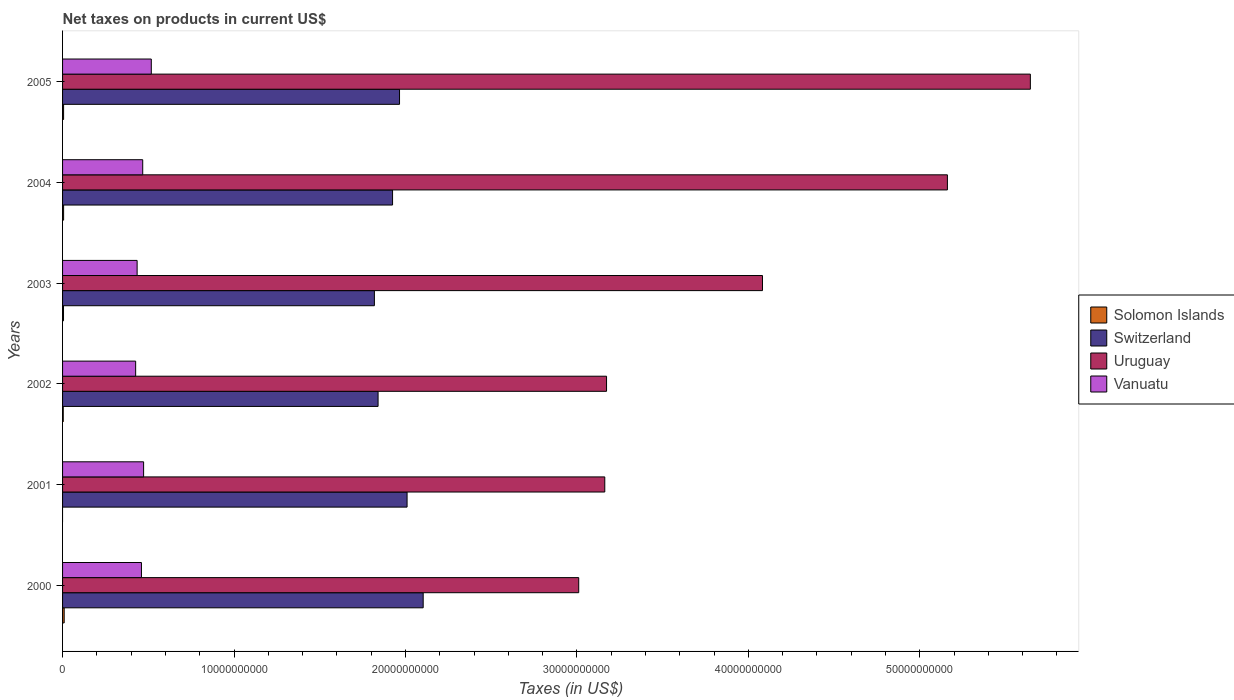How many groups of bars are there?
Your response must be concise. 6. How many bars are there on the 1st tick from the top?
Your answer should be compact. 4. How many bars are there on the 4th tick from the bottom?
Give a very brief answer. 4. What is the net taxes on products in Switzerland in 2002?
Your answer should be very brief. 1.84e+1. Across all years, what is the maximum net taxes on products in Solomon Islands?
Offer a very short reply. 9.44e+07. Across all years, what is the minimum net taxes on products in Switzerland?
Ensure brevity in your answer.  1.82e+1. What is the total net taxes on products in Solomon Islands in the graph?
Offer a terse response. 3.12e+08. What is the difference between the net taxes on products in Switzerland in 2000 and that in 2002?
Give a very brief answer. 2.63e+09. What is the difference between the net taxes on products in Uruguay in 2004 and the net taxes on products in Solomon Islands in 2005?
Provide a short and direct response. 5.16e+1. What is the average net taxes on products in Switzerland per year?
Give a very brief answer. 1.94e+1. In the year 2004, what is the difference between the net taxes on products in Vanuatu and net taxes on products in Uruguay?
Offer a terse response. -4.69e+1. What is the ratio of the net taxes on products in Vanuatu in 2002 to that in 2005?
Make the answer very short. 0.82. Is the difference between the net taxes on products in Vanuatu in 2000 and 2005 greater than the difference between the net taxes on products in Uruguay in 2000 and 2005?
Your response must be concise. Yes. What is the difference between the highest and the second highest net taxes on products in Vanuatu?
Offer a very short reply. 4.49e+08. What is the difference between the highest and the lowest net taxes on products in Uruguay?
Ensure brevity in your answer.  2.63e+1. In how many years, is the net taxes on products in Solomon Islands greater than the average net taxes on products in Solomon Islands taken over all years?
Provide a succinct answer. 4. Is it the case that in every year, the sum of the net taxes on products in Solomon Islands and net taxes on products in Uruguay is greater than the sum of net taxes on products in Vanuatu and net taxes on products in Switzerland?
Your answer should be very brief. No. How many bars are there?
Offer a terse response. 23. How many years are there in the graph?
Ensure brevity in your answer.  6. What is the difference between two consecutive major ticks on the X-axis?
Your answer should be very brief. 1.00e+1. Does the graph contain grids?
Give a very brief answer. No. Where does the legend appear in the graph?
Provide a succinct answer. Center right. How many legend labels are there?
Your answer should be very brief. 4. How are the legend labels stacked?
Provide a short and direct response. Vertical. What is the title of the graph?
Make the answer very short. Net taxes on products in current US$. What is the label or title of the X-axis?
Your answer should be very brief. Taxes (in US$). What is the label or title of the Y-axis?
Ensure brevity in your answer.  Years. What is the Taxes (in US$) in Solomon Islands in 2000?
Offer a terse response. 9.44e+07. What is the Taxes (in US$) in Switzerland in 2000?
Make the answer very short. 2.10e+1. What is the Taxes (in US$) of Uruguay in 2000?
Your answer should be very brief. 3.01e+1. What is the Taxes (in US$) in Vanuatu in 2000?
Make the answer very short. 4.60e+09. What is the Taxes (in US$) of Switzerland in 2001?
Offer a very short reply. 2.01e+1. What is the Taxes (in US$) of Uruguay in 2001?
Your answer should be very brief. 3.16e+1. What is the Taxes (in US$) of Vanuatu in 2001?
Provide a short and direct response. 4.73e+09. What is the Taxes (in US$) of Solomon Islands in 2002?
Ensure brevity in your answer.  4.03e+07. What is the Taxes (in US$) in Switzerland in 2002?
Your answer should be very brief. 1.84e+1. What is the Taxes (in US$) in Uruguay in 2002?
Your answer should be very brief. 3.17e+1. What is the Taxes (in US$) of Vanuatu in 2002?
Ensure brevity in your answer.  4.26e+09. What is the Taxes (in US$) of Solomon Islands in 2003?
Give a very brief answer. 5.58e+07. What is the Taxes (in US$) in Switzerland in 2003?
Your response must be concise. 1.82e+1. What is the Taxes (in US$) in Uruguay in 2003?
Keep it short and to the point. 4.08e+1. What is the Taxes (in US$) of Vanuatu in 2003?
Provide a short and direct response. 4.35e+09. What is the Taxes (in US$) of Solomon Islands in 2004?
Keep it short and to the point. 6.11e+07. What is the Taxes (in US$) in Switzerland in 2004?
Your answer should be very brief. 1.92e+1. What is the Taxes (in US$) in Uruguay in 2004?
Your answer should be very brief. 5.16e+1. What is the Taxes (in US$) in Vanuatu in 2004?
Offer a terse response. 4.68e+09. What is the Taxes (in US$) in Solomon Islands in 2005?
Offer a very short reply. 6.03e+07. What is the Taxes (in US$) of Switzerland in 2005?
Give a very brief answer. 1.97e+1. What is the Taxes (in US$) of Uruguay in 2005?
Offer a terse response. 5.64e+1. What is the Taxes (in US$) in Vanuatu in 2005?
Make the answer very short. 5.18e+09. Across all years, what is the maximum Taxes (in US$) of Solomon Islands?
Your answer should be compact. 9.44e+07. Across all years, what is the maximum Taxes (in US$) in Switzerland?
Keep it short and to the point. 2.10e+1. Across all years, what is the maximum Taxes (in US$) in Uruguay?
Provide a succinct answer. 5.64e+1. Across all years, what is the maximum Taxes (in US$) of Vanuatu?
Provide a succinct answer. 5.18e+09. Across all years, what is the minimum Taxes (in US$) of Switzerland?
Give a very brief answer. 1.82e+1. Across all years, what is the minimum Taxes (in US$) in Uruguay?
Provide a short and direct response. 3.01e+1. Across all years, what is the minimum Taxes (in US$) of Vanuatu?
Offer a terse response. 4.26e+09. What is the total Taxes (in US$) of Solomon Islands in the graph?
Ensure brevity in your answer.  3.12e+08. What is the total Taxes (in US$) of Switzerland in the graph?
Keep it short and to the point. 1.17e+11. What is the total Taxes (in US$) of Uruguay in the graph?
Your answer should be compact. 2.42e+11. What is the total Taxes (in US$) in Vanuatu in the graph?
Give a very brief answer. 2.78e+1. What is the difference between the Taxes (in US$) in Switzerland in 2000 and that in 2001?
Give a very brief answer. 9.39e+08. What is the difference between the Taxes (in US$) in Uruguay in 2000 and that in 2001?
Provide a short and direct response. -1.52e+09. What is the difference between the Taxes (in US$) of Vanuatu in 2000 and that in 2001?
Keep it short and to the point. -1.26e+08. What is the difference between the Taxes (in US$) of Solomon Islands in 2000 and that in 2002?
Keep it short and to the point. 5.41e+07. What is the difference between the Taxes (in US$) of Switzerland in 2000 and that in 2002?
Make the answer very short. 2.63e+09. What is the difference between the Taxes (in US$) of Uruguay in 2000 and that in 2002?
Keep it short and to the point. -1.62e+09. What is the difference between the Taxes (in US$) of Vanuatu in 2000 and that in 2002?
Your answer should be compact. 3.38e+08. What is the difference between the Taxes (in US$) of Solomon Islands in 2000 and that in 2003?
Keep it short and to the point. 3.86e+07. What is the difference between the Taxes (in US$) in Switzerland in 2000 and that in 2003?
Your answer should be compact. 2.85e+09. What is the difference between the Taxes (in US$) of Uruguay in 2000 and that in 2003?
Keep it short and to the point. -1.07e+1. What is the difference between the Taxes (in US$) in Vanuatu in 2000 and that in 2003?
Your answer should be compact. 2.52e+08. What is the difference between the Taxes (in US$) in Solomon Islands in 2000 and that in 2004?
Provide a short and direct response. 3.33e+07. What is the difference between the Taxes (in US$) of Switzerland in 2000 and that in 2004?
Make the answer very short. 1.79e+09. What is the difference between the Taxes (in US$) in Uruguay in 2000 and that in 2004?
Make the answer very short. -2.15e+1. What is the difference between the Taxes (in US$) of Vanuatu in 2000 and that in 2004?
Offer a terse response. -7.40e+07. What is the difference between the Taxes (in US$) of Solomon Islands in 2000 and that in 2005?
Make the answer very short. 3.41e+07. What is the difference between the Taxes (in US$) in Switzerland in 2000 and that in 2005?
Keep it short and to the point. 1.38e+09. What is the difference between the Taxes (in US$) in Uruguay in 2000 and that in 2005?
Your answer should be compact. -2.63e+1. What is the difference between the Taxes (in US$) of Vanuatu in 2000 and that in 2005?
Give a very brief answer. -5.75e+08. What is the difference between the Taxes (in US$) in Switzerland in 2001 and that in 2002?
Make the answer very short. 1.69e+09. What is the difference between the Taxes (in US$) of Uruguay in 2001 and that in 2002?
Make the answer very short. -1.03e+08. What is the difference between the Taxes (in US$) of Vanuatu in 2001 and that in 2002?
Provide a short and direct response. 4.64e+08. What is the difference between the Taxes (in US$) in Switzerland in 2001 and that in 2003?
Make the answer very short. 1.91e+09. What is the difference between the Taxes (in US$) in Uruguay in 2001 and that in 2003?
Provide a succinct answer. -9.20e+09. What is the difference between the Taxes (in US$) of Vanuatu in 2001 and that in 2003?
Ensure brevity in your answer.  3.78e+08. What is the difference between the Taxes (in US$) in Switzerland in 2001 and that in 2004?
Keep it short and to the point. 8.47e+08. What is the difference between the Taxes (in US$) in Uruguay in 2001 and that in 2004?
Provide a short and direct response. -2.00e+1. What is the difference between the Taxes (in US$) of Vanuatu in 2001 and that in 2004?
Offer a very short reply. 5.20e+07. What is the difference between the Taxes (in US$) of Switzerland in 2001 and that in 2005?
Your answer should be very brief. 4.40e+08. What is the difference between the Taxes (in US$) in Uruguay in 2001 and that in 2005?
Keep it short and to the point. -2.48e+1. What is the difference between the Taxes (in US$) in Vanuatu in 2001 and that in 2005?
Provide a succinct answer. -4.49e+08. What is the difference between the Taxes (in US$) of Solomon Islands in 2002 and that in 2003?
Provide a succinct answer. -1.55e+07. What is the difference between the Taxes (in US$) in Switzerland in 2002 and that in 2003?
Give a very brief answer. 2.15e+08. What is the difference between the Taxes (in US$) of Uruguay in 2002 and that in 2003?
Provide a short and direct response. -9.10e+09. What is the difference between the Taxes (in US$) of Vanuatu in 2002 and that in 2003?
Provide a short and direct response. -8.60e+07. What is the difference between the Taxes (in US$) in Solomon Islands in 2002 and that in 2004?
Give a very brief answer. -2.08e+07. What is the difference between the Taxes (in US$) of Switzerland in 2002 and that in 2004?
Keep it short and to the point. -8.44e+08. What is the difference between the Taxes (in US$) in Uruguay in 2002 and that in 2004?
Your response must be concise. -1.99e+1. What is the difference between the Taxes (in US$) in Vanuatu in 2002 and that in 2004?
Keep it short and to the point. -4.12e+08. What is the difference between the Taxes (in US$) of Solomon Islands in 2002 and that in 2005?
Your answer should be very brief. -2.00e+07. What is the difference between the Taxes (in US$) in Switzerland in 2002 and that in 2005?
Provide a succinct answer. -1.25e+09. What is the difference between the Taxes (in US$) in Uruguay in 2002 and that in 2005?
Offer a very short reply. -2.47e+1. What is the difference between the Taxes (in US$) of Vanuatu in 2002 and that in 2005?
Provide a succinct answer. -9.13e+08. What is the difference between the Taxes (in US$) of Solomon Islands in 2003 and that in 2004?
Give a very brief answer. -5.30e+06. What is the difference between the Taxes (in US$) in Switzerland in 2003 and that in 2004?
Your answer should be very brief. -1.06e+09. What is the difference between the Taxes (in US$) of Uruguay in 2003 and that in 2004?
Ensure brevity in your answer.  -1.08e+1. What is the difference between the Taxes (in US$) of Vanuatu in 2003 and that in 2004?
Your response must be concise. -3.26e+08. What is the difference between the Taxes (in US$) in Solomon Islands in 2003 and that in 2005?
Your answer should be very brief. -4.50e+06. What is the difference between the Taxes (in US$) of Switzerland in 2003 and that in 2005?
Offer a terse response. -1.47e+09. What is the difference between the Taxes (in US$) in Uruguay in 2003 and that in 2005?
Give a very brief answer. -1.56e+1. What is the difference between the Taxes (in US$) in Vanuatu in 2003 and that in 2005?
Your answer should be compact. -8.27e+08. What is the difference between the Taxes (in US$) in Switzerland in 2004 and that in 2005?
Your response must be concise. -4.07e+08. What is the difference between the Taxes (in US$) in Uruguay in 2004 and that in 2005?
Give a very brief answer. -4.84e+09. What is the difference between the Taxes (in US$) in Vanuatu in 2004 and that in 2005?
Make the answer very short. -5.01e+08. What is the difference between the Taxes (in US$) of Solomon Islands in 2000 and the Taxes (in US$) of Switzerland in 2001?
Your answer should be compact. -2.00e+1. What is the difference between the Taxes (in US$) in Solomon Islands in 2000 and the Taxes (in US$) in Uruguay in 2001?
Your answer should be very brief. -3.15e+1. What is the difference between the Taxes (in US$) in Solomon Islands in 2000 and the Taxes (in US$) in Vanuatu in 2001?
Offer a terse response. -4.63e+09. What is the difference between the Taxes (in US$) in Switzerland in 2000 and the Taxes (in US$) in Uruguay in 2001?
Ensure brevity in your answer.  -1.06e+1. What is the difference between the Taxes (in US$) in Switzerland in 2000 and the Taxes (in US$) in Vanuatu in 2001?
Give a very brief answer. 1.63e+1. What is the difference between the Taxes (in US$) of Uruguay in 2000 and the Taxes (in US$) of Vanuatu in 2001?
Provide a succinct answer. 2.54e+1. What is the difference between the Taxes (in US$) in Solomon Islands in 2000 and the Taxes (in US$) in Switzerland in 2002?
Offer a terse response. -1.83e+1. What is the difference between the Taxes (in US$) of Solomon Islands in 2000 and the Taxes (in US$) of Uruguay in 2002?
Provide a succinct answer. -3.16e+1. What is the difference between the Taxes (in US$) in Solomon Islands in 2000 and the Taxes (in US$) in Vanuatu in 2002?
Offer a terse response. -4.17e+09. What is the difference between the Taxes (in US$) in Switzerland in 2000 and the Taxes (in US$) in Uruguay in 2002?
Your answer should be compact. -1.07e+1. What is the difference between the Taxes (in US$) of Switzerland in 2000 and the Taxes (in US$) of Vanuatu in 2002?
Make the answer very short. 1.68e+1. What is the difference between the Taxes (in US$) in Uruguay in 2000 and the Taxes (in US$) in Vanuatu in 2002?
Give a very brief answer. 2.58e+1. What is the difference between the Taxes (in US$) of Solomon Islands in 2000 and the Taxes (in US$) of Switzerland in 2003?
Make the answer very short. -1.81e+1. What is the difference between the Taxes (in US$) of Solomon Islands in 2000 and the Taxes (in US$) of Uruguay in 2003?
Offer a terse response. -4.07e+1. What is the difference between the Taxes (in US$) of Solomon Islands in 2000 and the Taxes (in US$) of Vanuatu in 2003?
Keep it short and to the point. -4.25e+09. What is the difference between the Taxes (in US$) of Switzerland in 2000 and the Taxes (in US$) of Uruguay in 2003?
Offer a very short reply. -1.98e+1. What is the difference between the Taxes (in US$) of Switzerland in 2000 and the Taxes (in US$) of Vanuatu in 2003?
Keep it short and to the point. 1.67e+1. What is the difference between the Taxes (in US$) of Uruguay in 2000 and the Taxes (in US$) of Vanuatu in 2003?
Your response must be concise. 2.58e+1. What is the difference between the Taxes (in US$) in Solomon Islands in 2000 and the Taxes (in US$) in Switzerland in 2004?
Keep it short and to the point. -1.92e+1. What is the difference between the Taxes (in US$) in Solomon Islands in 2000 and the Taxes (in US$) in Uruguay in 2004?
Ensure brevity in your answer.  -5.15e+1. What is the difference between the Taxes (in US$) in Solomon Islands in 2000 and the Taxes (in US$) in Vanuatu in 2004?
Provide a succinct answer. -4.58e+09. What is the difference between the Taxes (in US$) of Switzerland in 2000 and the Taxes (in US$) of Uruguay in 2004?
Offer a very short reply. -3.06e+1. What is the difference between the Taxes (in US$) of Switzerland in 2000 and the Taxes (in US$) of Vanuatu in 2004?
Your response must be concise. 1.64e+1. What is the difference between the Taxes (in US$) of Uruguay in 2000 and the Taxes (in US$) of Vanuatu in 2004?
Offer a very short reply. 2.54e+1. What is the difference between the Taxes (in US$) of Solomon Islands in 2000 and the Taxes (in US$) of Switzerland in 2005?
Make the answer very short. -1.96e+1. What is the difference between the Taxes (in US$) of Solomon Islands in 2000 and the Taxes (in US$) of Uruguay in 2005?
Ensure brevity in your answer.  -5.64e+1. What is the difference between the Taxes (in US$) in Solomon Islands in 2000 and the Taxes (in US$) in Vanuatu in 2005?
Make the answer very short. -5.08e+09. What is the difference between the Taxes (in US$) of Switzerland in 2000 and the Taxes (in US$) of Uruguay in 2005?
Keep it short and to the point. -3.54e+1. What is the difference between the Taxes (in US$) in Switzerland in 2000 and the Taxes (in US$) in Vanuatu in 2005?
Ensure brevity in your answer.  1.59e+1. What is the difference between the Taxes (in US$) of Uruguay in 2000 and the Taxes (in US$) of Vanuatu in 2005?
Your answer should be very brief. 2.49e+1. What is the difference between the Taxes (in US$) in Switzerland in 2001 and the Taxes (in US$) in Uruguay in 2002?
Keep it short and to the point. -1.16e+1. What is the difference between the Taxes (in US$) of Switzerland in 2001 and the Taxes (in US$) of Vanuatu in 2002?
Ensure brevity in your answer.  1.58e+1. What is the difference between the Taxes (in US$) of Uruguay in 2001 and the Taxes (in US$) of Vanuatu in 2002?
Give a very brief answer. 2.74e+1. What is the difference between the Taxes (in US$) of Switzerland in 2001 and the Taxes (in US$) of Uruguay in 2003?
Make the answer very short. -2.07e+1. What is the difference between the Taxes (in US$) of Switzerland in 2001 and the Taxes (in US$) of Vanuatu in 2003?
Your answer should be very brief. 1.57e+1. What is the difference between the Taxes (in US$) in Uruguay in 2001 and the Taxes (in US$) in Vanuatu in 2003?
Offer a terse response. 2.73e+1. What is the difference between the Taxes (in US$) of Switzerland in 2001 and the Taxes (in US$) of Uruguay in 2004?
Your answer should be very brief. -3.15e+1. What is the difference between the Taxes (in US$) in Switzerland in 2001 and the Taxes (in US$) in Vanuatu in 2004?
Make the answer very short. 1.54e+1. What is the difference between the Taxes (in US$) in Uruguay in 2001 and the Taxes (in US$) in Vanuatu in 2004?
Your answer should be compact. 2.70e+1. What is the difference between the Taxes (in US$) in Switzerland in 2001 and the Taxes (in US$) in Uruguay in 2005?
Your answer should be very brief. -3.64e+1. What is the difference between the Taxes (in US$) in Switzerland in 2001 and the Taxes (in US$) in Vanuatu in 2005?
Your answer should be very brief. 1.49e+1. What is the difference between the Taxes (in US$) in Uruguay in 2001 and the Taxes (in US$) in Vanuatu in 2005?
Give a very brief answer. 2.65e+1. What is the difference between the Taxes (in US$) in Solomon Islands in 2002 and the Taxes (in US$) in Switzerland in 2003?
Provide a short and direct response. -1.81e+1. What is the difference between the Taxes (in US$) in Solomon Islands in 2002 and the Taxes (in US$) in Uruguay in 2003?
Offer a very short reply. -4.08e+1. What is the difference between the Taxes (in US$) in Solomon Islands in 2002 and the Taxes (in US$) in Vanuatu in 2003?
Provide a succinct answer. -4.31e+09. What is the difference between the Taxes (in US$) in Switzerland in 2002 and the Taxes (in US$) in Uruguay in 2003?
Provide a succinct answer. -2.24e+1. What is the difference between the Taxes (in US$) in Switzerland in 2002 and the Taxes (in US$) in Vanuatu in 2003?
Provide a succinct answer. 1.41e+1. What is the difference between the Taxes (in US$) of Uruguay in 2002 and the Taxes (in US$) of Vanuatu in 2003?
Your answer should be very brief. 2.74e+1. What is the difference between the Taxes (in US$) of Solomon Islands in 2002 and the Taxes (in US$) of Switzerland in 2004?
Provide a succinct answer. -1.92e+1. What is the difference between the Taxes (in US$) of Solomon Islands in 2002 and the Taxes (in US$) of Uruguay in 2004?
Provide a short and direct response. -5.16e+1. What is the difference between the Taxes (in US$) of Solomon Islands in 2002 and the Taxes (in US$) of Vanuatu in 2004?
Your response must be concise. -4.63e+09. What is the difference between the Taxes (in US$) of Switzerland in 2002 and the Taxes (in US$) of Uruguay in 2004?
Provide a succinct answer. -3.32e+1. What is the difference between the Taxes (in US$) in Switzerland in 2002 and the Taxes (in US$) in Vanuatu in 2004?
Provide a short and direct response. 1.37e+1. What is the difference between the Taxes (in US$) in Uruguay in 2002 and the Taxes (in US$) in Vanuatu in 2004?
Offer a terse response. 2.71e+1. What is the difference between the Taxes (in US$) of Solomon Islands in 2002 and the Taxes (in US$) of Switzerland in 2005?
Make the answer very short. -1.96e+1. What is the difference between the Taxes (in US$) in Solomon Islands in 2002 and the Taxes (in US$) in Uruguay in 2005?
Provide a short and direct response. -5.64e+1. What is the difference between the Taxes (in US$) of Solomon Islands in 2002 and the Taxes (in US$) of Vanuatu in 2005?
Your answer should be very brief. -5.14e+09. What is the difference between the Taxes (in US$) of Switzerland in 2002 and the Taxes (in US$) of Uruguay in 2005?
Provide a succinct answer. -3.80e+1. What is the difference between the Taxes (in US$) in Switzerland in 2002 and the Taxes (in US$) in Vanuatu in 2005?
Provide a succinct answer. 1.32e+1. What is the difference between the Taxes (in US$) of Uruguay in 2002 and the Taxes (in US$) of Vanuatu in 2005?
Make the answer very short. 2.66e+1. What is the difference between the Taxes (in US$) in Solomon Islands in 2003 and the Taxes (in US$) in Switzerland in 2004?
Ensure brevity in your answer.  -1.92e+1. What is the difference between the Taxes (in US$) in Solomon Islands in 2003 and the Taxes (in US$) in Uruguay in 2004?
Offer a terse response. -5.16e+1. What is the difference between the Taxes (in US$) of Solomon Islands in 2003 and the Taxes (in US$) of Vanuatu in 2004?
Ensure brevity in your answer.  -4.62e+09. What is the difference between the Taxes (in US$) in Switzerland in 2003 and the Taxes (in US$) in Uruguay in 2004?
Keep it short and to the point. -3.34e+1. What is the difference between the Taxes (in US$) of Switzerland in 2003 and the Taxes (in US$) of Vanuatu in 2004?
Provide a succinct answer. 1.35e+1. What is the difference between the Taxes (in US$) of Uruguay in 2003 and the Taxes (in US$) of Vanuatu in 2004?
Keep it short and to the point. 3.62e+1. What is the difference between the Taxes (in US$) in Solomon Islands in 2003 and the Taxes (in US$) in Switzerland in 2005?
Give a very brief answer. -1.96e+1. What is the difference between the Taxes (in US$) of Solomon Islands in 2003 and the Taxes (in US$) of Uruguay in 2005?
Provide a short and direct response. -5.64e+1. What is the difference between the Taxes (in US$) in Solomon Islands in 2003 and the Taxes (in US$) in Vanuatu in 2005?
Provide a succinct answer. -5.12e+09. What is the difference between the Taxes (in US$) in Switzerland in 2003 and the Taxes (in US$) in Uruguay in 2005?
Offer a very short reply. -3.83e+1. What is the difference between the Taxes (in US$) in Switzerland in 2003 and the Taxes (in US$) in Vanuatu in 2005?
Your answer should be very brief. 1.30e+1. What is the difference between the Taxes (in US$) in Uruguay in 2003 and the Taxes (in US$) in Vanuatu in 2005?
Ensure brevity in your answer.  3.56e+1. What is the difference between the Taxes (in US$) in Solomon Islands in 2004 and the Taxes (in US$) in Switzerland in 2005?
Provide a succinct answer. -1.96e+1. What is the difference between the Taxes (in US$) in Solomon Islands in 2004 and the Taxes (in US$) in Uruguay in 2005?
Your response must be concise. -5.64e+1. What is the difference between the Taxes (in US$) of Solomon Islands in 2004 and the Taxes (in US$) of Vanuatu in 2005?
Offer a very short reply. -5.11e+09. What is the difference between the Taxes (in US$) in Switzerland in 2004 and the Taxes (in US$) in Uruguay in 2005?
Give a very brief answer. -3.72e+1. What is the difference between the Taxes (in US$) of Switzerland in 2004 and the Taxes (in US$) of Vanuatu in 2005?
Give a very brief answer. 1.41e+1. What is the difference between the Taxes (in US$) in Uruguay in 2004 and the Taxes (in US$) in Vanuatu in 2005?
Keep it short and to the point. 4.64e+1. What is the average Taxes (in US$) of Solomon Islands per year?
Provide a succinct answer. 5.20e+07. What is the average Taxes (in US$) of Switzerland per year?
Your answer should be very brief. 1.94e+1. What is the average Taxes (in US$) in Uruguay per year?
Keep it short and to the point. 4.04e+1. What is the average Taxes (in US$) in Vanuatu per year?
Your response must be concise. 4.63e+09. In the year 2000, what is the difference between the Taxes (in US$) in Solomon Islands and Taxes (in US$) in Switzerland?
Keep it short and to the point. -2.09e+1. In the year 2000, what is the difference between the Taxes (in US$) in Solomon Islands and Taxes (in US$) in Uruguay?
Ensure brevity in your answer.  -3.00e+1. In the year 2000, what is the difference between the Taxes (in US$) in Solomon Islands and Taxes (in US$) in Vanuatu?
Your answer should be compact. -4.51e+09. In the year 2000, what is the difference between the Taxes (in US$) in Switzerland and Taxes (in US$) in Uruguay?
Give a very brief answer. -9.07e+09. In the year 2000, what is the difference between the Taxes (in US$) in Switzerland and Taxes (in US$) in Vanuatu?
Your answer should be very brief. 1.64e+1. In the year 2000, what is the difference between the Taxes (in US$) of Uruguay and Taxes (in US$) of Vanuatu?
Offer a terse response. 2.55e+1. In the year 2001, what is the difference between the Taxes (in US$) in Switzerland and Taxes (in US$) in Uruguay?
Make the answer very short. -1.15e+1. In the year 2001, what is the difference between the Taxes (in US$) in Switzerland and Taxes (in US$) in Vanuatu?
Provide a succinct answer. 1.54e+1. In the year 2001, what is the difference between the Taxes (in US$) of Uruguay and Taxes (in US$) of Vanuatu?
Provide a short and direct response. 2.69e+1. In the year 2002, what is the difference between the Taxes (in US$) in Solomon Islands and Taxes (in US$) in Switzerland?
Provide a short and direct response. -1.84e+1. In the year 2002, what is the difference between the Taxes (in US$) of Solomon Islands and Taxes (in US$) of Uruguay?
Make the answer very short. -3.17e+1. In the year 2002, what is the difference between the Taxes (in US$) of Solomon Islands and Taxes (in US$) of Vanuatu?
Ensure brevity in your answer.  -4.22e+09. In the year 2002, what is the difference between the Taxes (in US$) of Switzerland and Taxes (in US$) of Uruguay?
Ensure brevity in your answer.  -1.33e+1. In the year 2002, what is the difference between the Taxes (in US$) in Switzerland and Taxes (in US$) in Vanuatu?
Provide a short and direct response. 1.41e+1. In the year 2002, what is the difference between the Taxes (in US$) in Uruguay and Taxes (in US$) in Vanuatu?
Offer a very short reply. 2.75e+1. In the year 2003, what is the difference between the Taxes (in US$) of Solomon Islands and Taxes (in US$) of Switzerland?
Offer a terse response. -1.81e+1. In the year 2003, what is the difference between the Taxes (in US$) in Solomon Islands and Taxes (in US$) in Uruguay?
Make the answer very short. -4.08e+1. In the year 2003, what is the difference between the Taxes (in US$) in Solomon Islands and Taxes (in US$) in Vanuatu?
Provide a succinct answer. -4.29e+09. In the year 2003, what is the difference between the Taxes (in US$) in Switzerland and Taxes (in US$) in Uruguay?
Give a very brief answer. -2.26e+1. In the year 2003, what is the difference between the Taxes (in US$) in Switzerland and Taxes (in US$) in Vanuatu?
Provide a short and direct response. 1.38e+1. In the year 2003, what is the difference between the Taxes (in US$) in Uruguay and Taxes (in US$) in Vanuatu?
Ensure brevity in your answer.  3.65e+1. In the year 2004, what is the difference between the Taxes (in US$) of Solomon Islands and Taxes (in US$) of Switzerland?
Your answer should be compact. -1.92e+1. In the year 2004, what is the difference between the Taxes (in US$) of Solomon Islands and Taxes (in US$) of Uruguay?
Provide a succinct answer. -5.16e+1. In the year 2004, what is the difference between the Taxes (in US$) of Solomon Islands and Taxes (in US$) of Vanuatu?
Ensure brevity in your answer.  -4.61e+09. In the year 2004, what is the difference between the Taxes (in US$) in Switzerland and Taxes (in US$) in Uruguay?
Your answer should be very brief. -3.24e+1. In the year 2004, what is the difference between the Taxes (in US$) of Switzerland and Taxes (in US$) of Vanuatu?
Keep it short and to the point. 1.46e+1. In the year 2004, what is the difference between the Taxes (in US$) in Uruguay and Taxes (in US$) in Vanuatu?
Provide a short and direct response. 4.69e+1. In the year 2005, what is the difference between the Taxes (in US$) of Solomon Islands and Taxes (in US$) of Switzerland?
Provide a succinct answer. -1.96e+1. In the year 2005, what is the difference between the Taxes (in US$) in Solomon Islands and Taxes (in US$) in Uruguay?
Offer a very short reply. -5.64e+1. In the year 2005, what is the difference between the Taxes (in US$) in Solomon Islands and Taxes (in US$) in Vanuatu?
Ensure brevity in your answer.  -5.12e+09. In the year 2005, what is the difference between the Taxes (in US$) in Switzerland and Taxes (in US$) in Uruguay?
Give a very brief answer. -3.68e+1. In the year 2005, what is the difference between the Taxes (in US$) of Switzerland and Taxes (in US$) of Vanuatu?
Provide a short and direct response. 1.45e+1. In the year 2005, what is the difference between the Taxes (in US$) of Uruguay and Taxes (in US$) of Vanuatu?
Provide a succinct answer. 5.13e+1. What is the ratio of the Taxes (in US$) of Switzerland in 2000 to that in 2001?
Provide a succinct answer. 1.05. What is the ratio of the Taxes (in US$) in Uruguay in 2000 to that in 2001?
Provide a short and direct response. 0.95. What is the ratio of the Taxes (in US$) in Vanuatu in 2000 to that in 2001?
Your answer should be very brief. 0.97. What is the ratio of the Taxes (in US$) in Solomon Islands in 2000 to that in 2002?
Your answer should be compact. 2.34. What is the ratio of the Taxes (in US$) in Switzerland in 2000 to that in 2002?
Provide a short and direct response. 1.14. What is the ratio of the Taxes (in US$) of Uruguay in 2000 to that in 2002?
Keep it short and to the point. 0.95. What is the ratio of the Taxes (in US$) of Vanuatu in 2000 to that in 2002?
Provide a short and direct response. 1.08. What is the ratio of the Taxes (in US$) in Solomon Islands in 2000 to that in 2003?
Offer a very short reply. 1.69. What is the ratio of the Taxes (in US$) of Switzerland in 2000 to that in 2003?
Ensure brevity in your answer.  1.16. What is the ratio of the Taxes (in US$) of Uruguay in 2000 to that in 2003?
Keep it short and to the point. 0.74. What is the ratio of the Taxes (in US$) of Vanuatu in 2000 to that in 2003?
Offer a terse response. 1.06. What is the ratio of the Taxes (in US$) of Solomon Islands in 2000 to that in 2004?
Ensure brevity in your answer.  1.54. What is the ratio of the Taxes (in US$) in Switzerland in 2000 to that in 2004?
Provide a succinct answer. 1.09. What is the ratio of the Taxes (in US$) in Uruguay in 2000 to that in 2004?
Ensure brevity in your answer.  0.58. What is the ratio of the Taxes (in US$) in Vanuatu in 2000 to that in 2004?
Your answer should be compact. 0.98. What is the ratio of the Taxes (in US$) in Solomon Islands in 2000 to that in 2005?
Ensure brevity in your answer.  1.57. What is the ratio of the Taxes (in US$) of Switzerland in 2000 to that in 2005?
Keep it short and to the point. 1.07. What is the ratio of the Taxes (in US$) in Uruguay in 2000 to that in 2005?
Your answer should be very brief. 0.53. What is the ratio of the Taxes (in US$) of Vanuatu in 2000 to that in 2005?
Make the answer very short. 0.89. What is the ratio of the Taxes (in US$) in Switzerland in 2001 to that in 2002?
Offer a very short reply. 1.09. What is the ratio of the Taxes (in US$) in Vanuatu in 2001 to that in 2002?
Offer a terse response. 1.11. What is the ratio of the Taxes (in US$) of Switzerland in 2001 to that in 2003?
Ensure brevity in your answer.  1.1. What is the ratio of the Taxes (in US$) of Uruguay in 2001 to that in 2003?
Your answer should be compact. 0.77. What is the ratio of the Taxes (in US$) of Vanuatu in 2001 to that in 2003?
Keep it short and to the point. 1.09. What is the ratio of the Taxes (in US$) of Switzerland in 2001 to that in 2004?
Your response must be concise. 1.04. What is the ratio of the Taxes (in US$) in Uruguay in 2001 to that in 2004?
Give a very brief answer. 0.61. What is the ratio of the Taxes (in US$) of Vanuatu in 2001 to that in 2004?
Ensure brevity in your answer.  1.01. What is the ratio of the Taxes (in US$) in Switzerland in 2001 to that in 2005?
Make the answer very short. 1.02. What is the ratio of the Taxes (in US$) of Uruguay in 2001 to that in 2005?
Give a very brief answer. 0.56. What is the ratio of the Taxes (in US$) in Vanuatu in 2001 to that in 2005?
Your answer should be compact. 0.91. What is the ratio of the Taxes (in US$) of Solomon Islands in 2002 to that in 2003?
Ensure brevity in your answer.  0.72. What is the ratio of the Taxes (in US$) of Switzerland in 2002 to that in 2003?
Provide a succinct answer. 1.01. What is the ratio of the Taxes (in US$) of Uruguay in 2002 to that in 2003?
Offer a very short reply. 0.78. What is the ratio of the Taxes (in US$) of Vanuatu in 2002 to that in 2003?
Your answer should be very brief. 0.98. What is the ratio of the Taxes (in US$) of Solomon Islands in 2002 to that in 2004?
Offer a terse response. 0.66. What is the ratio of the Taxes (in US$) in Switzerland in 2002 to that in 2004?
Your answer should be compact. 0.96. What is the ratio of the Taxes (in US$) in Uruguay in 2002 to that in 2004?
Offer a terse response. 0.61. What is the ratio of the Taxes (in US$) in Vanuatu in 2002 to that in 2004?
Provide a succinct answer. 0.91. What is the ratio of the Taxes (in US$) of Solomon Islands in 2002 to that in 2005?
Offer a terse response. 0.67. What is the ratio of the Taxes (in US$) of Switzerland in 2002 to that in 2005?
Offer a terse response. 0.94. What is the ratio of the Taxes (in US$) of Uruguay in 2002 to that in 2005?
Provide a succinct answer. 0.56. What is the ratio of the Taxes (in US$) in Vanuatu in 2002 to that in 2005?
Provide a succinct answer. 0.82. What is the ratio of the Taxes (in US$) in Solomon Islands in 2003 to that in 2004?
Give a very brief answer. 0.91. What is the ratio of the Taxes (in US$) in Switzerland in 2003 to that in 2004?
Keep it short and to the point. 0.94. What is the ratio of the Taxes (in US$) of Uruguay in 2003 to that in 2004?
Your answer should be very brief. 0.79. What is the ratio of the Taxes (in US$) of Vanuatu in 2003 to that in 2004?
Your answer should be very brief. 0.93. What is the ratio of the Taxes (in US$) of Solomon Islands in 2003 to that in 2005?
Your answer should be very brief. 0.93. What is the ratio of the Taxes (in US$) of Switzerland in 2003 to that in 2005?
Provide a succinct answer. 0.93. What is the ratio of the Taxes (in US$) of Uruguay in 2003 to that in 2005?
Provide a short and direct response. 0.72. What is the ratio of the Taxes (in US$) of Vanuatu in 2003 to that in 2005?
Your response must be concise. 0.84. What is the ratio of the Taxes (in US$) in Solomon Islands in 2004 to that in 2005?
Make the answer very short. 1.01. What is the ratio of the Taxes (in US$) in Switzerland in 2004 to that in 2005?
Your response must be concise. 0.98. What is the ratio of the Taxes (in US$) in Uruguay in 2004 to that in 2005?
Make the answer very short. 0.91. What is the ratio of the Taxes (in US$) in Vanuatu in 2004 to that in 2005?
Offer a terse response. 0.9. What is the difference between the highest and the second highest Taxes (in US$) of Solomon Islands?
Your answer should be very brief. 3.33e+07. What is the difference between the highest and the second highest Taxes (in US$) in Switzerland?
Offer a very short reply. 9.39e+08. What is the difference between the highest and the second highest Taxes (in US$) in Uruguay?
Provide a short and direct response. 4.84e+09. What is the difference between the highest and the second highest Taxes (in US$) in Vanuatu?
Provide a short and direct response. 4.49e+08. What is the difference between the highest and the lowest Taxes (in US$) of Solomon Islands?
Offer a terse response. 9.44e+07. What is the difference between the highest and the lowest Taxes (in US$) in Switzerland?
Your answer should be very brief. 2.85e+09. What is the difference between the highest and the lowest Taxes (in US$) in Uruguay?
Offer a very short reply. 2.63e+1. What is the difference between the highest and the lowest Taxes (in US$) in Vanuatu?
Your answer should be compact. 9.13e+08. 